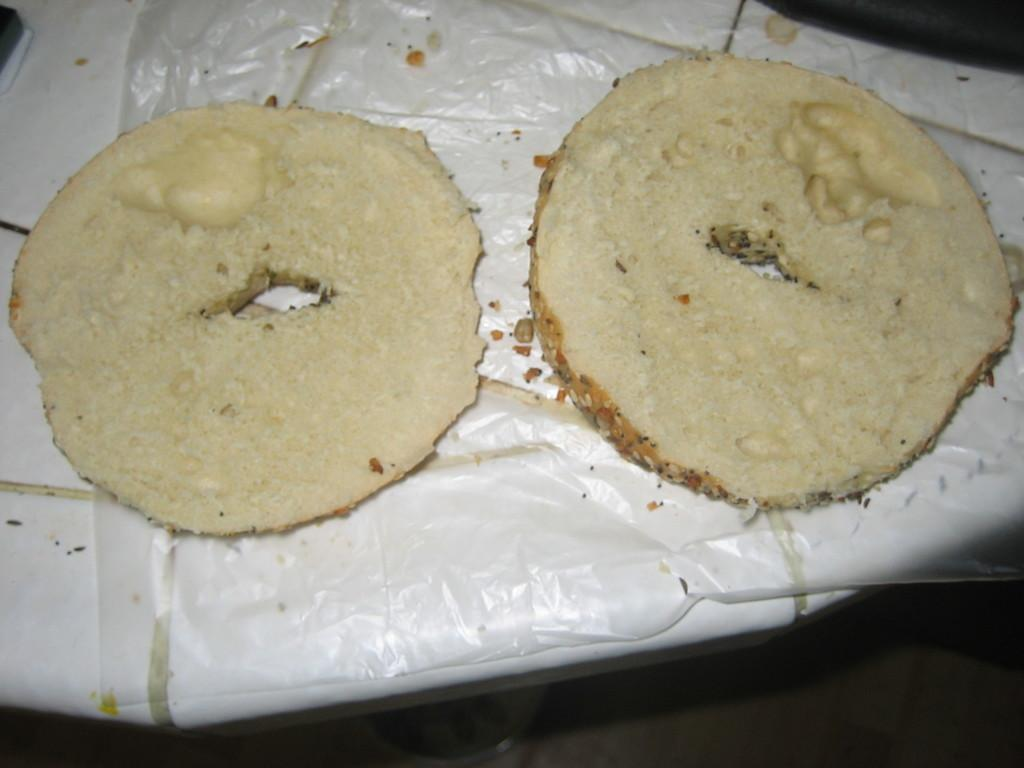What is the color of the main object in the image? The main object in the image is white. What is on top of the white object? There is a doughnut on the white object. How is the doughnut sliced? The doughnut is sliced into half. What colors can be seen on the doughnut? The doughnut is brown and cream in color. What is the color of the background in the image? The background of the image is black. What type of church can be seen in the background of the image? There is no church present in the image; the background is black. 